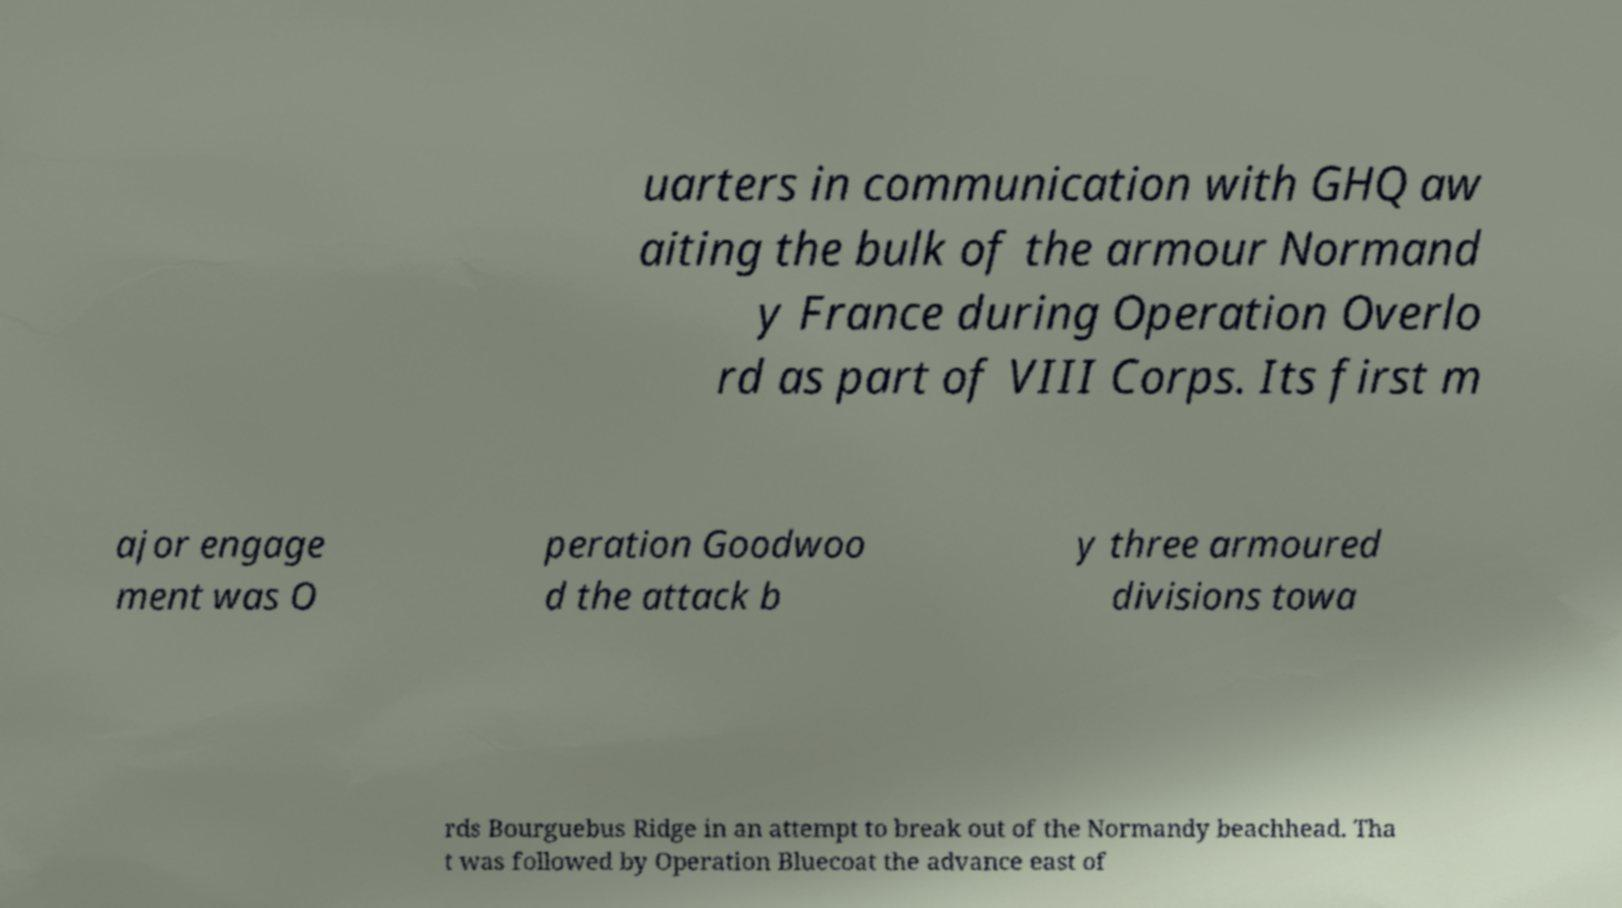What messages or text are displayed in this image? I need them in a readable, typed format. uarters in communication with GHQ aw aiting the bulk of the armour Normand y France during Operation Overlo rd as part of VIII Corps. Its first m ajor engage ment was O peration Goodwoo d the attack b y three armoured divisions towa rds Bourguebus Ridge in an attempt to break out of the Normandy beachhead. Tha t was followed by Operation Bluecoat the advance east of 